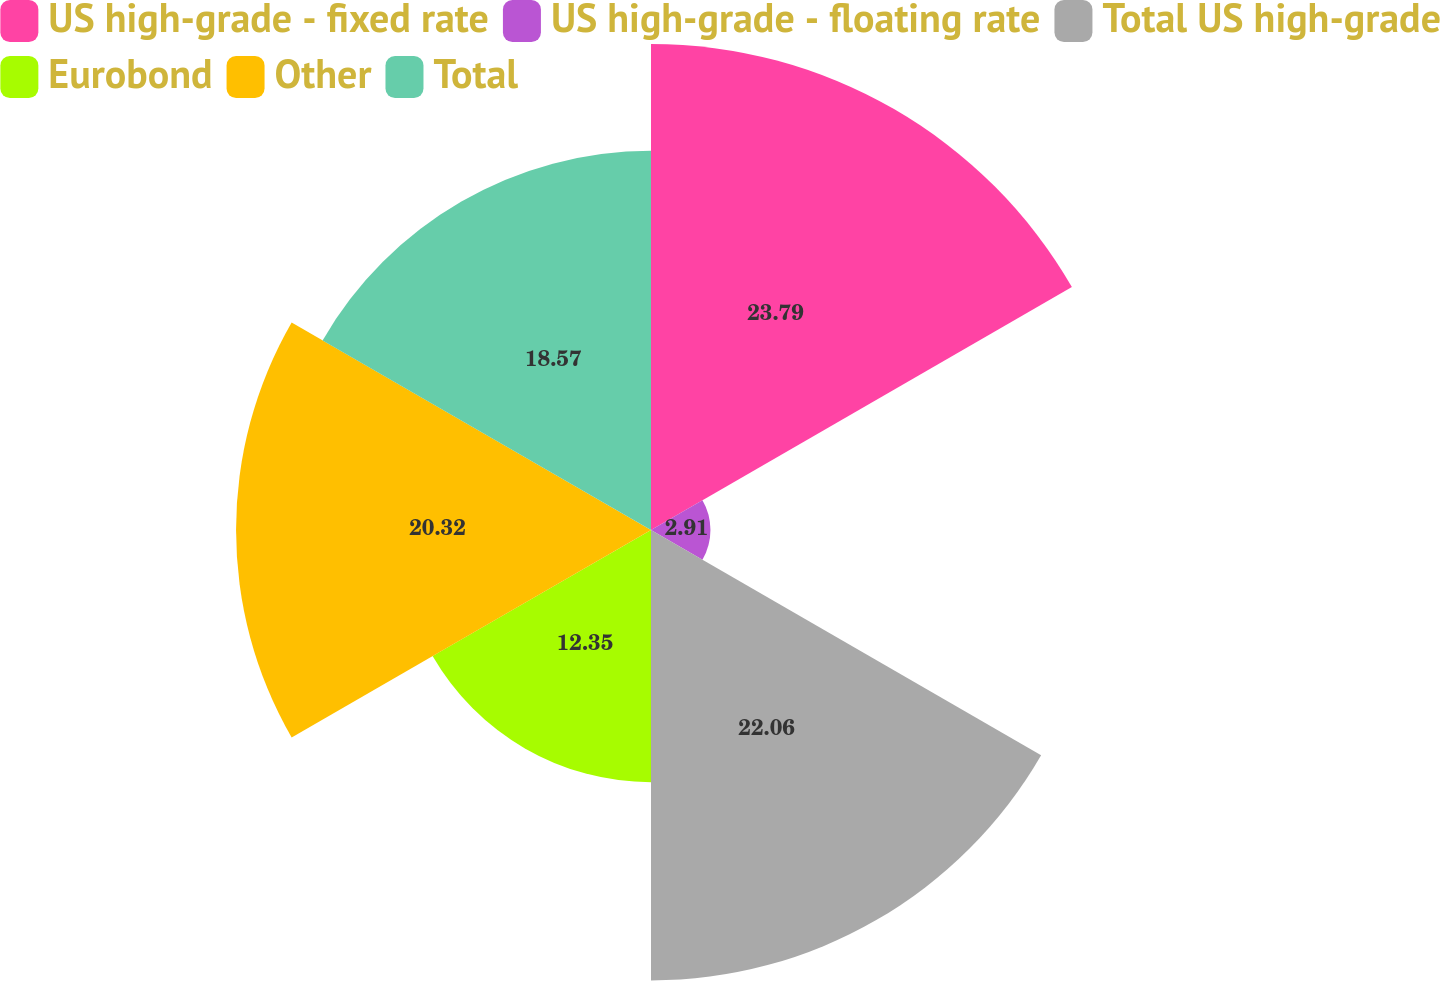Convert chart. <chart><loc_0><loc_0><loc_500><loc_500><pie_chart><fcel>US high-grade - fixed rate<fcel>US high-grade - floating rate<fcel>Total US high-grade<fcel>Eurobond<fcel>Other<fcel>Total<nl><fcel>23.8%<fcel>2.91%<fcel>22.06%<fcel>12.35%<fcel>20.32%<fcel>18.57%<nl></chart> 